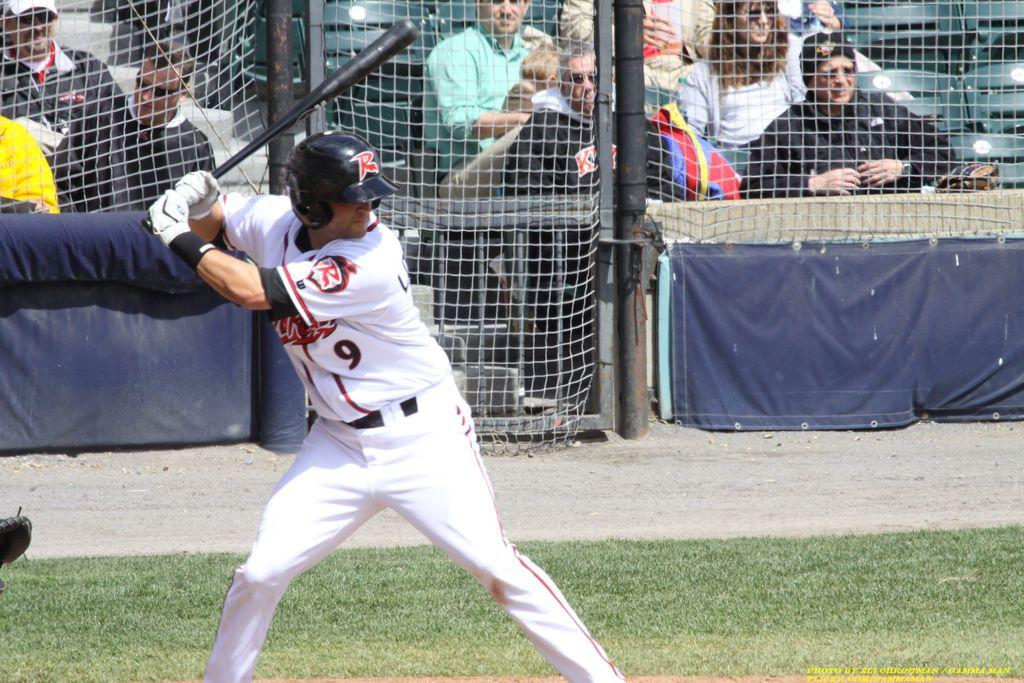<image>
Give a short and clear explanation of the subsequent image. Player number 9 stands at the plate and readies for the pitch. 